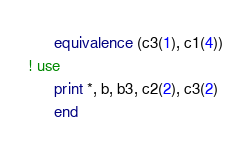Convert code to text. <code><loc_0><loc_0><loc_500><loc_500><_FORTRAN_>      equivalence (c3(1), c1(4))
! use
      print *, b, b3, c2(2), c3(2)
      end
</code> 